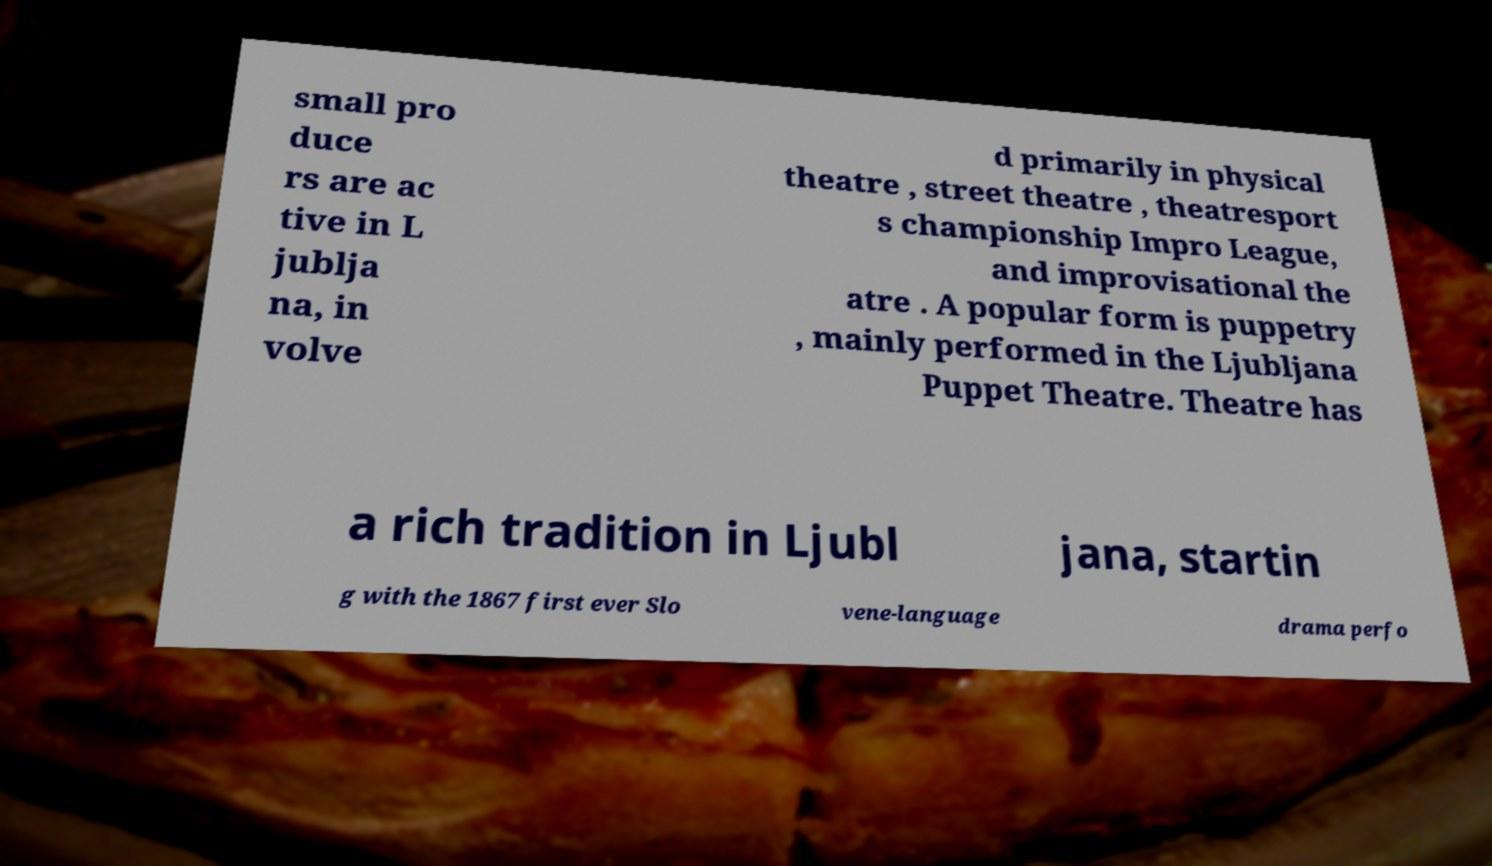There's text embedded in this image that I need extracted. Can you transcribe it verbatim? small pro duce rs are ac tive in L jublja na, in volve d primarily in physical theatre , street theatre , theatresport s championship Impro League, and improvisational the atre . A popular form is puppetry , mainly performed in the Ljubljana Puppet Theatre. Theatre has a rich tradition in Ljubl jana, startin g with the 1867 first ever Slo vene-language drama perfo 